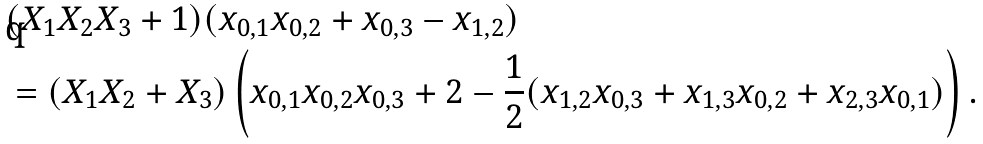Convert formula to latex. <formula><loc_0><loc_0><loc_500><loc_500>& ( X _ { 1 } X _ { 2 } X _ { 3 } + 1 ) ( x _ { 0 , 1 } x _ { 0 , 2 } + x _ { 0 , 3 } - x _ { 1 , 2 } ) \\ & = ( X _ { 1 } X _ { 2 } + X _ { 3 } ) \left ( x _ { 0 , 1 } x _ { 0 , 2 } x _ { 0 , 3 } + 2 - \frac { 1 } { 2 } ( x _ { 1 , 2 } x _ { 0 , 3 } + x _ { 1 , 3 } x _ { 0 , 2 } + x _ { 2 , 3 } x _ { 0 , 1 } ) \right ) .</formula> 